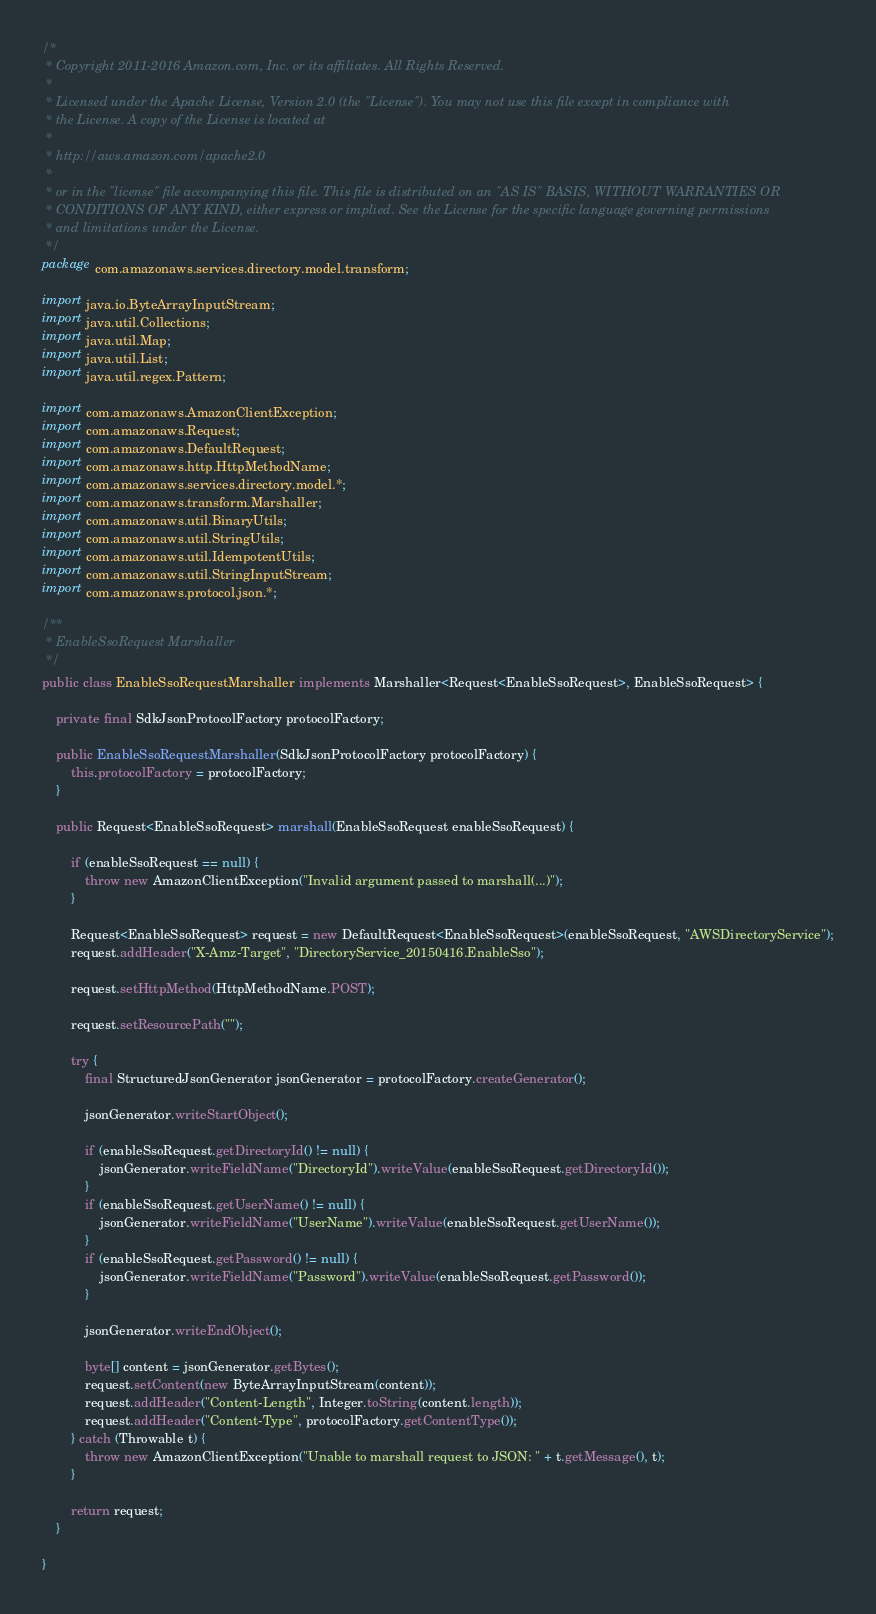Convert code to text. <code><loc_0><loc_0><loc_500><loc_500><_Java_>/*
 * Copyright 2011-2016 Amazon.com, Inc. or its affiliates. All Rights Reserved.
 * 
 * Licensed under the Apache License, Version 2.0 (the "License"). You may not use this file except in compliance with
 * the License. A copy of the License is located at
 * 
 * http://aws.amazon.com/apache2.0
 * 
 * or in the "license" file accompanying this file. This file is distributed on an "AS IS" BASIS, WITHOUT WARRANTIES OR
 * CONDITIONS OF ANY KIND, either express or implied. See the License for the specific language governing permissions
 * and limitations under the License.
 */
package com.amazonaws.services.directory.model.transform;

import java.io.ByteArrayInputStream;
import java.util.Collections;
import java.util.Map;
import java.util.List;
import java.util.regex.Pattern;

import com.amazonaws.AmazonClientException;
import com.amazonaws.Request;
import com.amazonaws.DefaultRequest;
import com.amazonaws.http.HttpMethodName;
import com.amazonaws.services.directory.model.*;
import com.amazonaws.transform.Marshaller;
import com.amazonaws.util.BinaryUtils;
import com.amazonaws.util.StringUtils;
import com.amazonaws.util.IdempotentUtils;
import com.amazonaws.util.StringInputStream;
import com.amazonaws.protocol.json.*;

/**
 * EnableSsoRequest Marshaller
 */
public class EnableSsoRequestMarshaller implements Marshaller<Request<EnableSsoRequest>, EnableSsoRequest> {

    private final SdkJsonProtocolFactory protocolFactory;

    public EnableSsoRequestMarshaller(SdkJsonProtocolFactory protocolFactory) {
        this.protocolFactory = protocolFactory;
    }

    public Request<EnableSsoRequest> marshall(EnableSsoRequest enableSsoRequest) {

        if (enableSsoRequest == null) {
            throw new AmazonClientException("Invalid argument passed to marshall(...)");
        }

        Request<EnableSsoRequest> request = new DefaultRequest<EnableSsoRequest>(enableSsoRequest, "AWSDirectoryService");
        request.addHeader("X-Amz-Target", "DirectoryService_20150416.EnableSso");

        request.setHttpMethod(HttpMethodName.POST);

        request.setResourcePath("");

        try {
            final StructuredJsonGenerator jsonGenerator = protocolFactory.createGenerator();

            jsonGenerator.writeStartObject();

            if (enableSsoRequest.getDirectoryId() != null) {
                jsonGenerator.writeFieldName("DirectoryId").writeValue(enableSsoRequest.getDirectoryId());
            }
            if (enableSsoRequest.getUserName() != null) {
                jsonGenerator.writeFieldName("UserName").writeValue(enableSsoRequest.getUserName());
            }
            if (enableSsoRequest.getPassword() != null) {
                jsonGenerator.writeFieldName("Password").writeValue(enableSsoRequest.getPassword());
            }

            jsonGenerator.writeEndObject();

            byte[] content = jsonGenerator.getBytes();
            request.setContent(new ByteArrayInputStream(content));
            request.addHeader("Content-Length", Integer.toString(content.length));
            request.addHeader("Content-Type", protocolFactory.getContentType());
        } catch (Throwable t) {
            throw new AmazonClientException("Unable to marshall request to JSON: " + t.getMessage(), t);
        }

        return request;
    }

}
</code> 